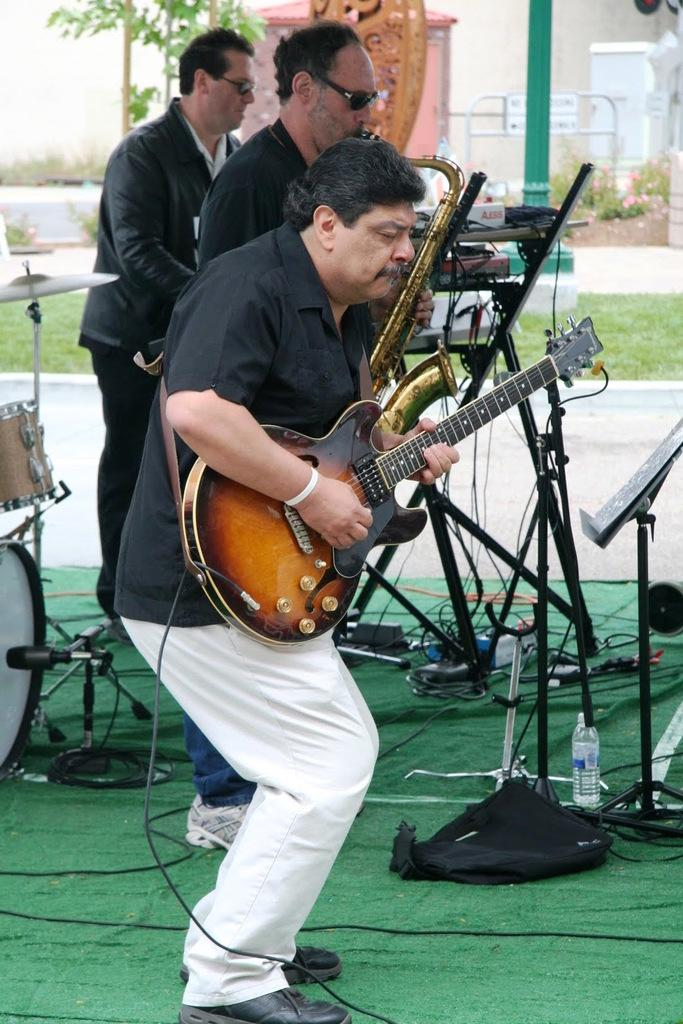How many people are in the image? There are three persons in the image. What are the persons doing in the image? The persons are playing musical instruments. Can you describe any objects in the image besides the musical instruments? Yes, there is a bottle, grass, plants, and a pole in the image. What type of pipe can be seen in the image? There is no pipe present in the image. Can you describe the clouds in the image? There are no clouds visible in the image. 